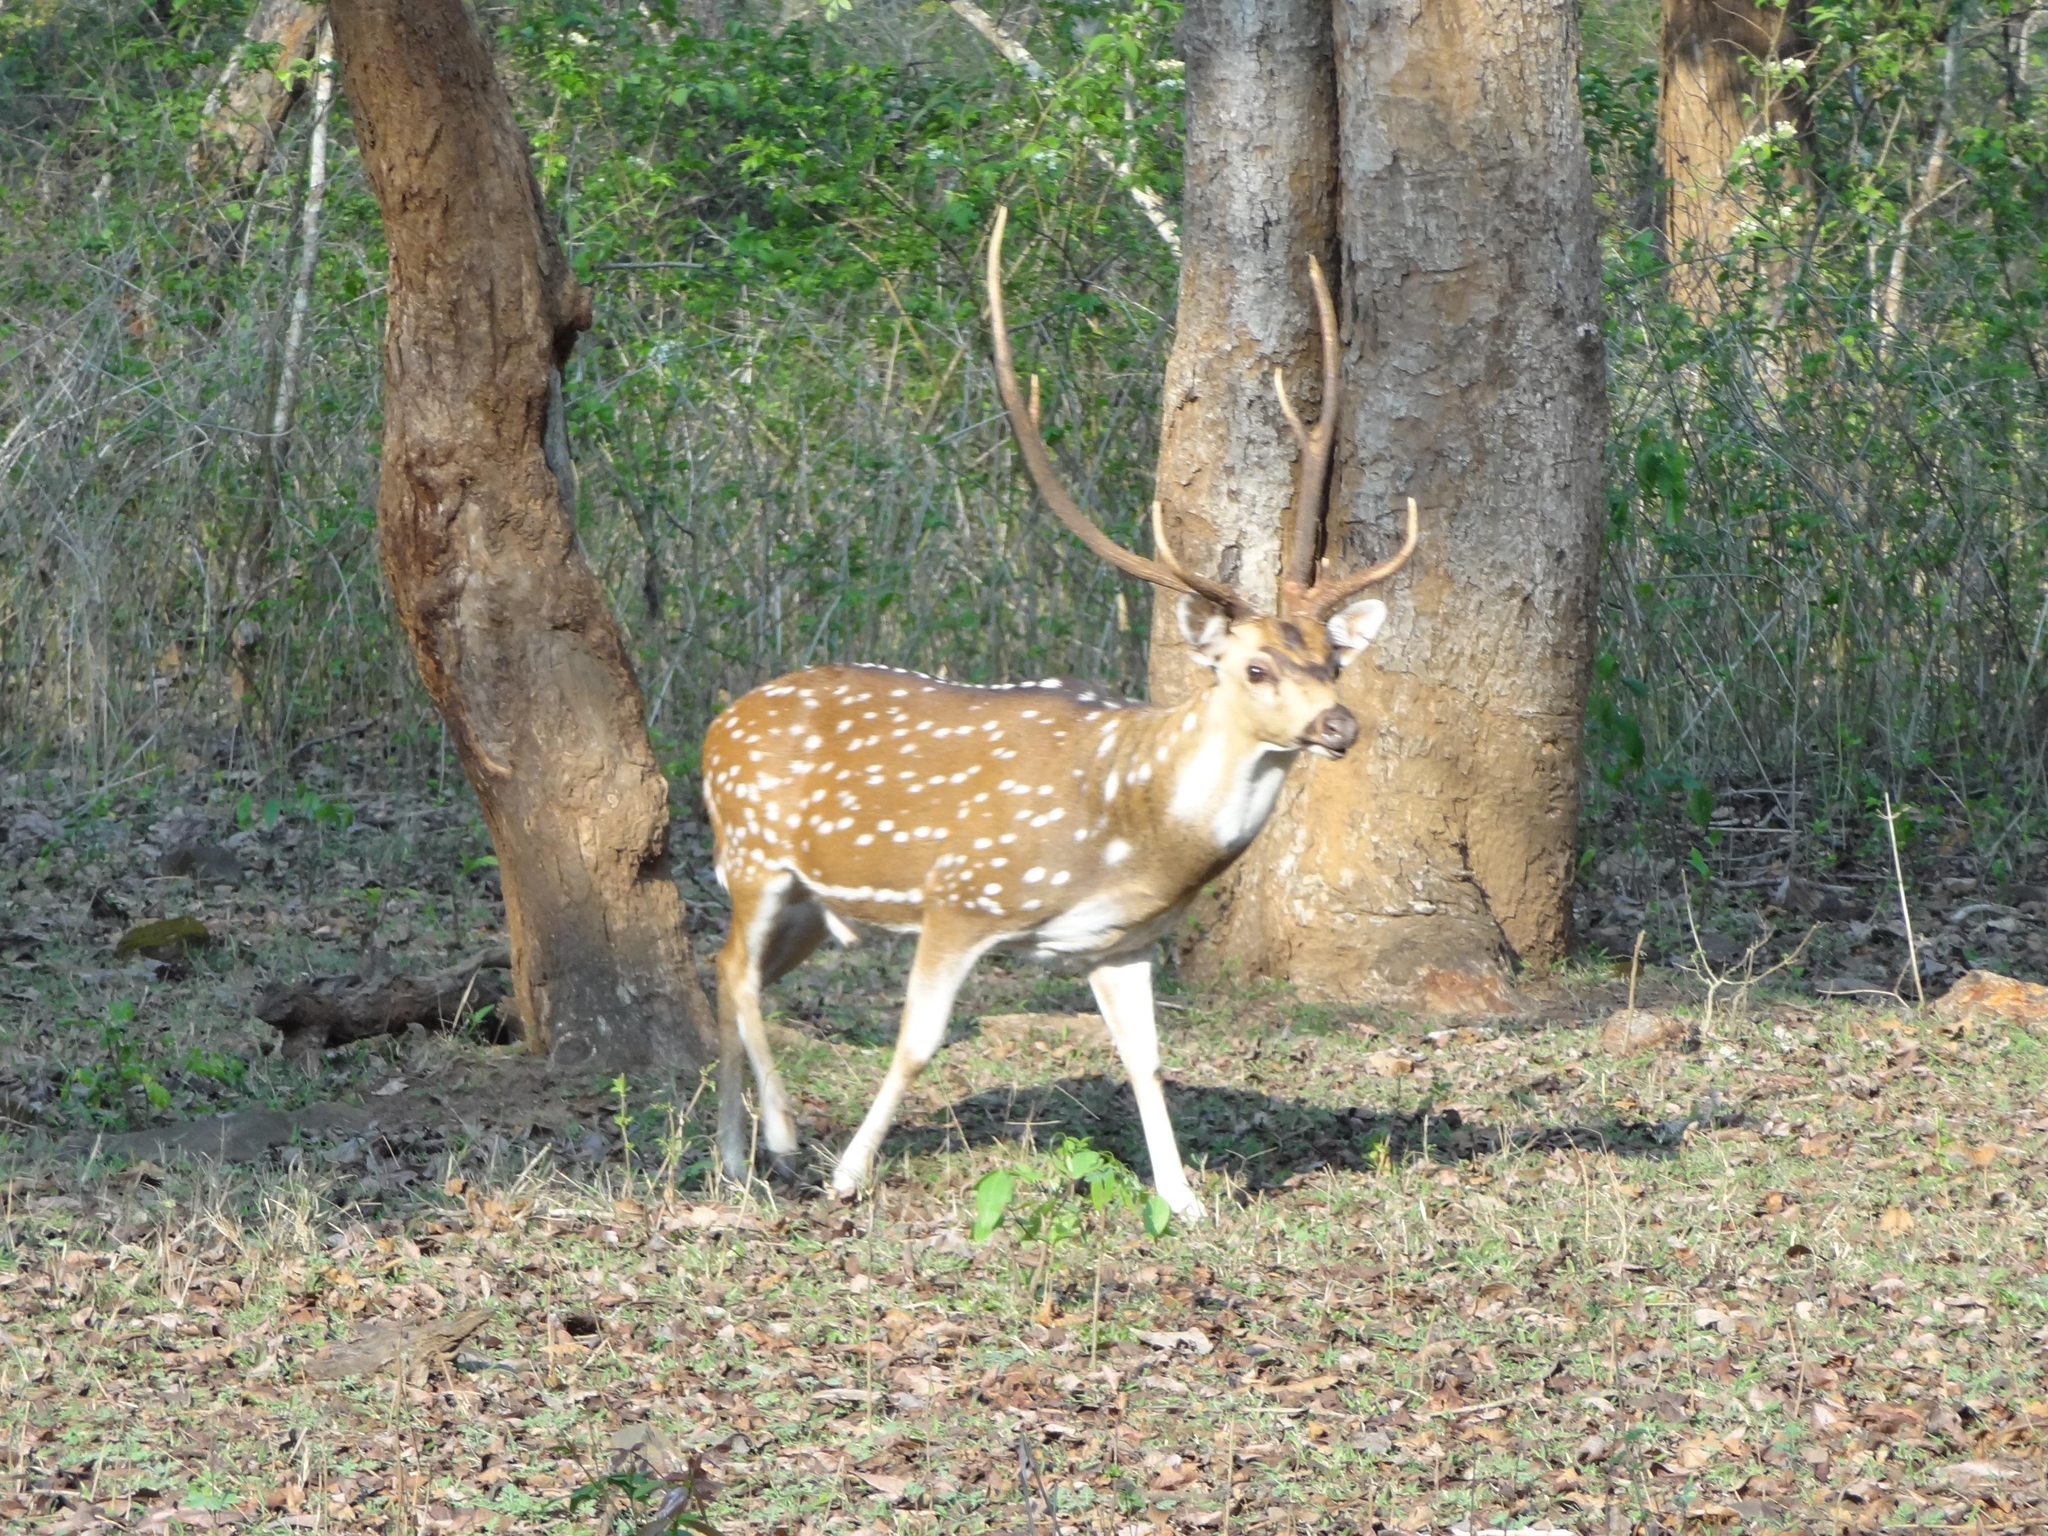What animal is in the center of the image? There is a deer in the center of the image. Where is the deer located? The deer is on the ground. What can be seen in the background of the image? There are trees in the background of the image. What type of meat is the deer holding in the image? The deer is not holding any meat in the image; it is a wild animal and does not carry food items. 